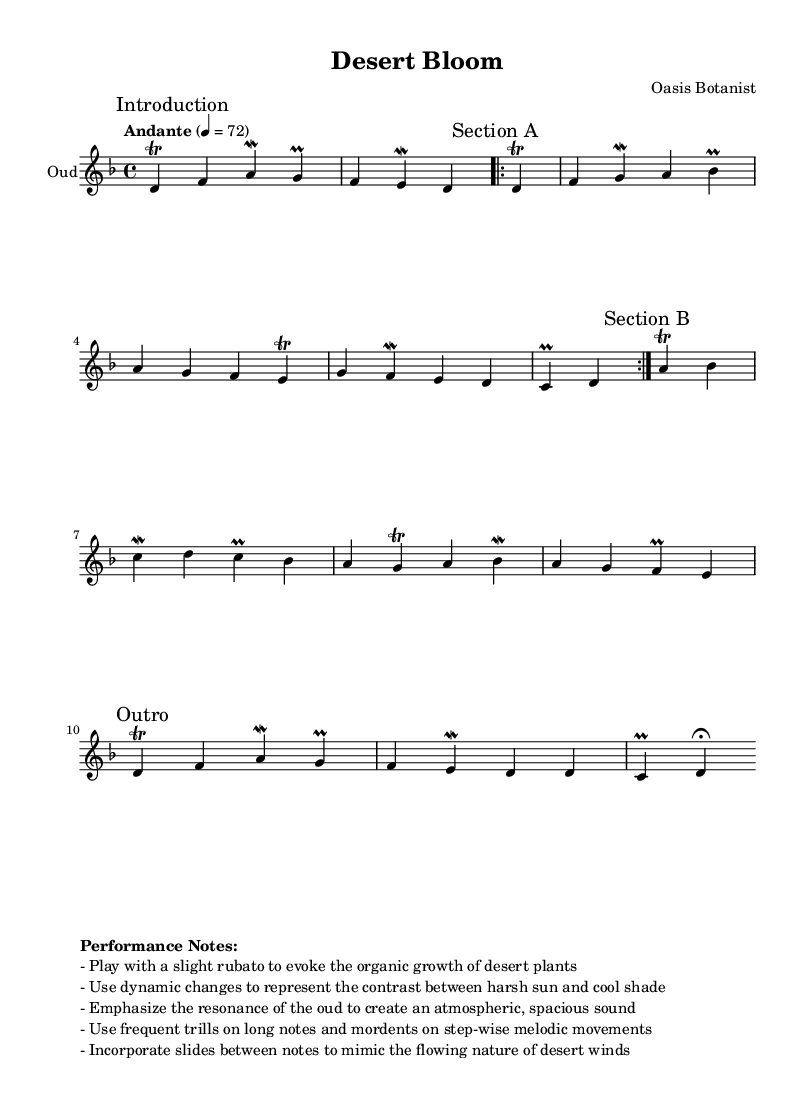What is the key signature of this music? The key signature is D minor, which has one flat (B flat). This can be identified by looking at the key signature indication after the clef at the beginning of the sheet music.
Answer: D minor What is the time signature of this piece? The time signature is 4/4, indicated at the beginning of the score. This means there are four beats in a measure and the quarter note receives one beat.
Answer: 4/4 What is the tempo marking for this composition? The tempo marking is "Andante," suggesting a moderately slow tempo. This is found in the tempo indication section of the score.
Answer: Andante How many sections are there in this piece? There are three main sections: Introduction, Section A, Section B, and an Outro. This can be determined by reviewing the section markings provided in the score.
Answer: 4 What types of ornaments are used frequently in this music? Trills and mordents are used frequently, as noted in the performance instructions and indicated by the musical symbols on specific notes throughout the piece.
Answer: Trills and mordents What musical technique is suggested to mimic the flowing nature of desert winds? The piece suggests the use of slides between notes, which is specified in the performance notes. This technique will help evoke the imagery of organic movements akin to desert winds.
Answer: Slides 